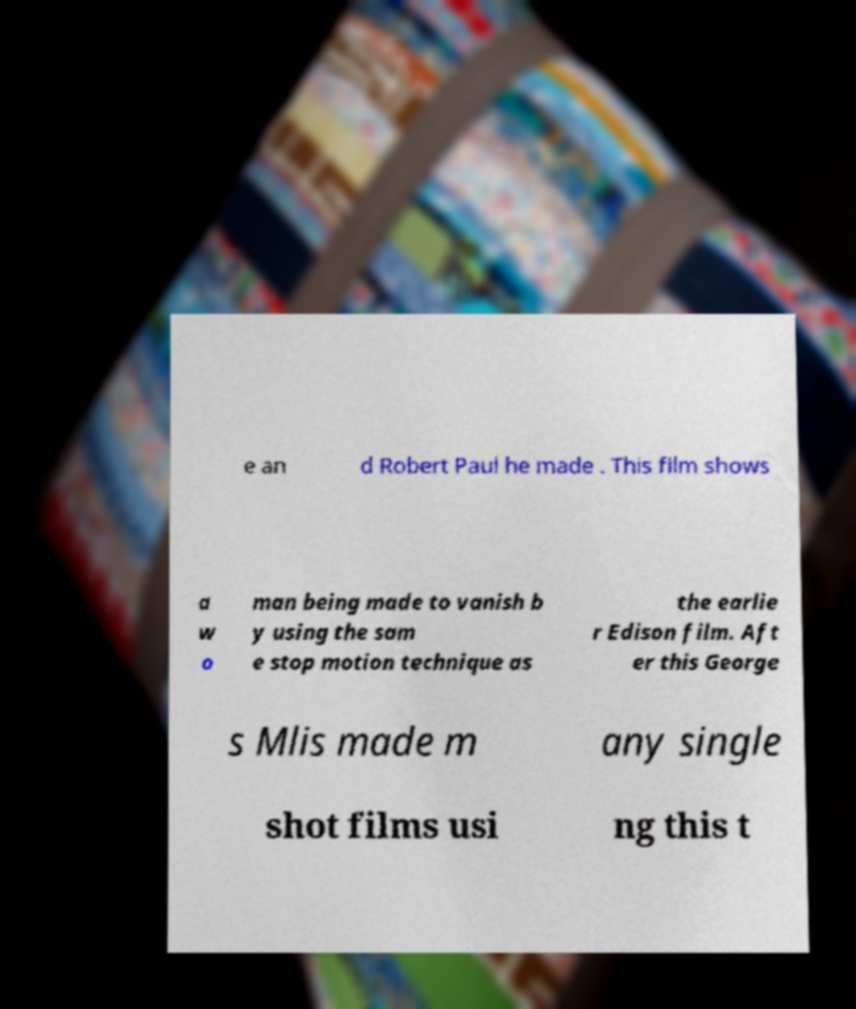Please read and relay the text visible in this image. What does it say? e an d Robert Paul he made . This film shows a w o man being made to vanish b y using the sam e stop motion technique as the earlie r Edison film. Aft er this George s Mlis made m any single shot films usi ng this t 